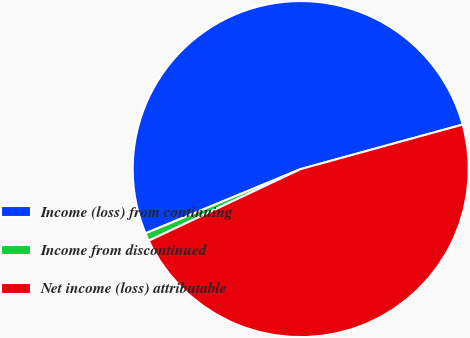Convert chart. <chart><loc_0><loc_0><loc_500><loc_500><pie_chart><fcel>Income (loss) from continuing<fcel>Income from discontinued<fcel>Net income (loss) attributable<nl><fcel>51.98%<fcel>0.76%<fcel>47.26%<nl></chart> 